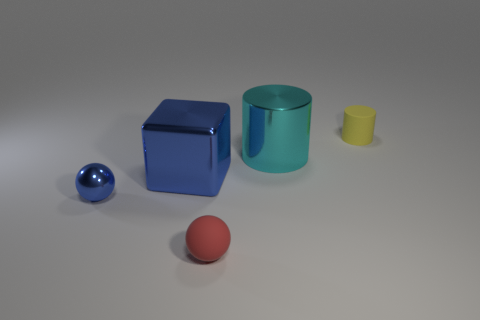Are there any tiny rubber objects of the same color as the small metal thing?
Provide a succinct answer. No. The cylinder that is the same size as the red matte sphere is what color?
Provide a short and direct response. Yellow. What number of small objects are blue metallic blocks or things?
Make the answer very short. 3. Are there an equal number of objects that are left of the metal sphere and metallic blocks that are on the right side of the matte cylinder?
Make the answer very short. Yes. What number of cyan things are the same size as the red rubber ball?
Give a very brief answer. 0. What number of yellow objects are small metallic balls or rubber objects?
Your response must be concise. 1. Are there the same number of big cyan cylinders that are on the right side of the tiny yellow matte object and cyan metal cylinders?
Ensure brevity in your answer.  No. There is a block that is behind the tiny red sphere; what is its size?
Offer a very short reply. Large. How many big things are the same shape as the small metal object?
Keep it short and to the point. 0. What is the material of the thing that is on the left side of the red matte sphere and in front of the big blue object?
Make the answer very short. Metal. 